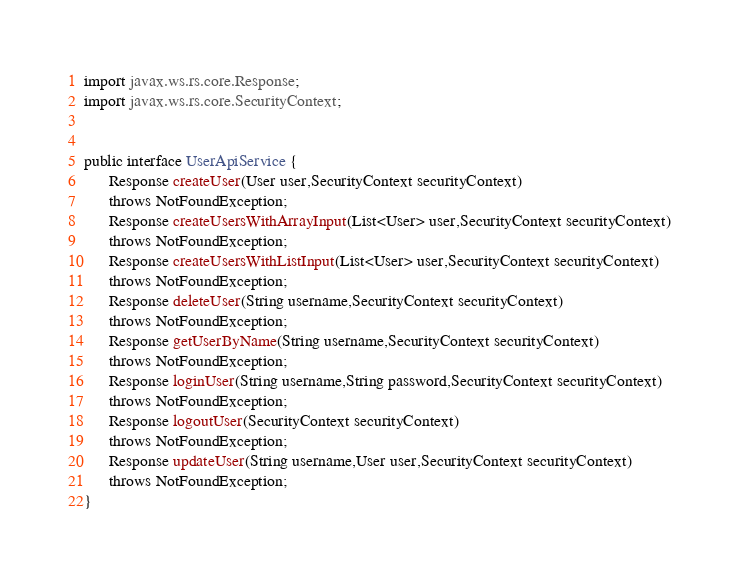Convert code to text. <code><loc_0><loc_0><loc_500><loc_500><_Java_>import javax.ws.rs.core.Response;
import javax.ws.rs.core.SecurityContext;


public interface UserApiService {
      Response createUser(User user,SecurityContext securityContext)
      throws NotFoundException;
      Response createUsersWithArrayInput(List<User> user,SecurityContext securityContext)
      throws NotFoundException;
      Response createUsersWithListInput(List<User> user,SecurityContext securityContext)
      throws NotFoundException;
      Response deleteUser(String username,SecurityContext securityContext)
      throws NotFoundException;
      Response getUserByName(String username,SecurityContext securityContext)
      throws NotFoundException;
      Response loginUser(String username,String password,SecurityContext securityContext)
      throws NotFoundException;
      Response logoutUser(SecurityContext securityContext)
      throws NotFoundException;
      Response updateUser(String username,User user,SecurityContext securityContext)
      throws NotFoundException;
}
</code> 